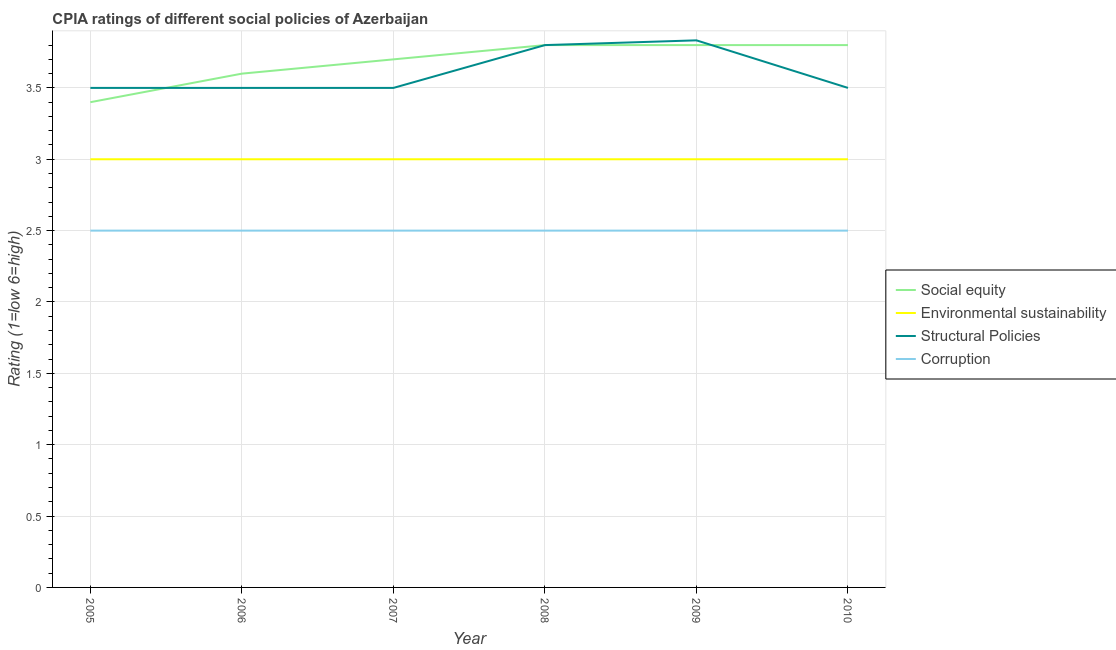Does the line corresponding to cpia rating of corruption intersect with the line corresponding to cpia rating of environmental sustainability?
Your answer should be compact. No. Across all years, what is the maximum cpia rating of environmental sustainability?
Offer a terse response. 3. Across all years, what is the minimum cpia rating of structural policies?
Your answer should be compact. 3.5. In which year was the cpia rating of social equity minimum?
Provide a short and direct response. 2005. What is the total cpia rating of social equity in the graph?
Ensure brevity in your answer.  22.1. What is the difference between the cpia rating of social equity in 2005 and that in 2009?
Ensure brevity in your answer.  -0.4. What is the average cpia rating of environmental sustainability per year?
Offer a very short reply. 3. In the year 2010, what is the difference between the cpia rating of corruption and cpia rating of environmental sustainability?
Offer a very short reply. -0.5. What is the ratio of the cpia rating of structural policies in 2007 to that in 2009?
Keep it short and to the point. 0.91. What is the difference between the highest and the second highest cpia rating of environmental sustainability?
Keep it short and to the point. 0. What is the difference between the highest and the lowest cpia rating of structural policies?
Provide a succinct answer. 0.33. In how many years, is the cpia rating of social equity greater than the average cpia rating of social equity taken over all years?
Your response must be concise. 4. Is the sum of the cpia rating of corruption in 2005 and 2010 greater than the maximum cpia rating of environmental sustainability across all years?
Give a very brief answer. Yes. Is it the case that in every year, the sum of the cpia rating of structural policies and cpia rating of corruption is greater than the sum of cpia rating of environmental sustainability and cpia rating of social equity?
Offer a terse response. No. Is the cpia rating of environmental sustainability strictly less than the cpia rating of structural policies over the years?
Your answer should be very brief. Yes. What is the difference between two consecutive major ticks on the Y-axis?
Give a very brief answer. 0.5. Are the values on the major ticks of Y-axis written in scientific E-notation?
Your answer should be compact. No. Does the graph contain grids?
Offer a terse response. Yes. What is the title of the graph?
Give a very brief answer. CPIA ratings of different social policies of Azerbaijan. Does "Mammal species" appear as one of the legend labels in the graph?
Provide a short and direct response. No. What is the label or title of the Y-axis?
Your answer should be compact. Rating (1=low 6=high). What is the Rating (1=low 6=high) in Social equity in 2005?
Your answer should be very brief. 3.4. What is the Rating (1=low 6=high) of Environmental sustainability in 2005?
Your answer should be very brief. 3. What is the Rating (1=low 6=high) in Corruption in 2005?
Your response must be concise. 2.5. What is the Rating (1=low 6=high) of Social equity in 2007?
Make the answer very short. 3.7. What is the Rating (1=low 6=high) in Environmental sustainability in 2007?
Offer a very short reply. 3. What is the Rating (1=low 6=high) in Structural Policies in 2007?
Your response must be concise. 3.5. What is the Rating (1=low 6=high) of Corruption in 2007?
Make the answer very short. 2.5. What is the Rating (1=low 6=high) of Environmental sustainability in 2008?
Ensure brevity in your answer.  3. What is the Rating (1=low 6=high) in Social equity in 2009?
Your answer should be very brief. 3.8. What is the Rating (1=low 6=high) of Structural Policies in 2009?
Your answer should be compact. 3.83. What is the Rating (1=low 6=high) in Social equity in 2010?
Your answer should be very brief. 3.8. What is the Rating (1=low 6=high) of Environmental sustainability in 2010?
Offer a very short reply. 3. What is the Rating (1=low 6=high) of Structural Policies in 2010?
Ensure brevity in your answer.  3.5. What is the Rating (1=low 6=high) in Corruption in 2010?
Keep it short and to the point. 2.5. Across all years, what is the maximum Rating (1=low 6=high) of Social equity?
Your answer should be very brief. 3.8. Across all years, what is the maximum Rating (1=low 6=high) in Structural Policies?
Ensure brevity in your answer.  3.83. Across all years, what is the minimum Rating (1=low 6=high) in Social equity?
Make the answer very short. 3.4. Across all years, what is the minimum Rating (1=low 6=high) in Environmental sustainability?
Offer a terse response. 3. What is the total Rating (1=low 6=high) of Social equity in the graph?
Give a very brief answer. 22.1. What is the total Rating (1=low 6=high) in Structural Policies in the graph?
Give a very brief answer. 21.63. What is the difference between the Rating (1=low 6=high) of Environmental sustainability in 2005 and that in 2006?
Keep it short and to the point. 0. What is the difference between the Rating (1=low 6=high) of Corruption in 2005 and that in 2006?
Ensure brevity in your answer.  0. What is the difference between the Rating (1=low 6=high) in Corruption in 2005 and that in 2007?
Provide a succinct answer. 0. What is the difference between the Rating (1=low 6=high) in Environmental sustainability in 2005 and that in 2008?
Provide a short and direct response. 0. What is the difference between the Rating (1=low 6=high) in Structural Policies in 2005 and that in 2008?
Give a very brief answer. -0.3. What is the difference between the Rating (1=low 6=high) of Corruption in 2005 and that in 2008?
Ensure brevity in your answer.  0. What is the difference between the Rating (1=low 6=high) in Social equity in 2005 and that in 2009?
Make the answer very short. -0.4. What is the difference between the Rating (1=low 6=high) of Environmental sustainability in 2005 and that in 2009?
Your answer should be very brief. 0. What is the difference between the Rating (1=low 6=high) in Structural Policies in 2005 and that in 2009?
Give a very brief answer. -0.33. What is the difference between the Rating (1=low 6=high) in Corruption in 2005 and that in 2009?
Ensure brevity in your answer.  0. What is the difference between the Rating (1=low 6=high) of Social equity in 2005 and that in 2010?
Provide a succinct answer. -0.4. What is the difference between the Rating (1=low 6=high) in Structural Policies in 2006 and that in 2007?
Provide a succinct answer. 0. What is the difference between the Rating (1=low 6=high) of Social equity in 2006 and that in 2008?
Your response must be concise. -0.2. What is the difference between the Rating (1=low 6=high) of Structural Policies in 2006 and that in 2008?
Ensure brevity in your answer.  -0.3. What is the difference between the Rating (1=low 6=high) in Corruption in 2006 and that in 2008?
Keep it short and to the point. 0. What is the difference between the Rating (1=low 6=high) in Environmental sustainability in 2006 and that in 2010?
Your response must be concise. 0. What is the difference between the Rating (1=low 6=high) of Structural Policies in 2006 and that in 2010?
Offer a very short reply. 0. What is the difference between the Rating (1=low 6=high) in Social equity in 2007 and that in 2008?
Offer a terse response. -0.1. What is the difference between the Rating (1=low 6=high) in Environmental sustainability in 2007 and that in 2008?
Keep it short and to the point. 0. What is the difference between the Rating (1=low 6=high) in Structural Policies in 2007 and that in 2008?
Your answer should be compact. -0.3. What is the difference between the Rating (1=low 6=high) in Corruption in 2007 and that in 2008?
Provide a short and direct response. 0. What is the difference between the Rating (1=low 6=high) in Environmental sustainability in 2007 and that in 2009?
Offer a very short reply. 0. What is the difference between the Rating (1=low 6=high) in Environmental sustainability in 2007 and that in 2010?
Provide a succinct answer. 0. What is the difference between the Rating (1=low 6=high) of Structural Policies in 2007 and that in 2010?
Make the answer very short. 0. What is the difference between the Rating (1=low 6=high) in Corruption in 2007 and that in 2010?
Your answer should be very brief. 0. What is the difference between the Rating (1=low 6=high) of Environmental sustainability in 2008 and that in 2009?
Offer a terse response. 0. What is the difference between the Rating (1=low 6=high) of Structural Policies in 2008 and that in 2009?
Make the answer very short. -0.03. What is the difference between the Rating (1=low 6=high) in Corruption in 2008 and that in 2009?
Keep it short and to the point. 0. What is the difference between the Rating (1=low 6=high) of Structural Policies in 2008 and that in 2010?
Your response must be concise. 0.3. What is the difference between the Rating (1=low 6=high) of Corruption in 2008 and that in 2010?
Ensure brevity in your answer.  0. What is the difference between the Rating (1=low 6=high) in Structural Policies in 2009 and that in 2010?
Your answer should be compact. 0.33. What is the difference between the Rating (1=low 6=high) of Corruption in 2009 and that in 2010?
Offer a very short reply. 0. What is the difference between the Rating (1=low 6=high) of Environmental sustainability in 2005 and the Rating (1=low 6=high) of Structural Policies in 2006?
Ensure brevity in your answer.  -0.5. What is the difference between the Rating (1=low 6=high) of Structural Policies in 2005 and the Rating (1=low 6=high) of Corruption in 2006?
Provide a succinct answer. 1. What is the difference between the Rating (1=low 6=high) of Social equity in 2005 and the Rating (1=low 6=high) of Structural Policies in 2007?
Provide a succinct answer. -0.1. What is the difference between the Rating (1=low 6=high) of Environmental sustainability in 2005 and the Rating (1=low 6=high) of Structural Policies in 2007?
Provide a succinct answer. -0.5. What is the difference between the Rating (1=low 6=high) of Social equity in 2005 and the Rating (1=low 6=high) of Structural Policies in 2008?
Ensure brevity in your answer.  -0.4. What is the difference between the Rating (1=low 6=high) of Social equity in 2005 and the Rating (1=low 6=high) of Corruption in 2008?
Provide a succinct answer. 0.9. What is the difference between the Rating (1=low 6=high) in Environmental sustainability in 2005 and the Rating (1=low 6=high) in Corruption in 2008?
Give a very brief answer. 0.5. What is the difference between the Rating (1=low 6=high) in Social equity in 2005 and the Rating (1=low 6=high) in Environmental sustainability in 2009?
Your response must be concise. 0.4. What is the difference between the Rating (1=low 6=high) of Social equity in 2005 and the Rating (1=low 6=high) of Structural Policies in 2009?
Keep it short and to the point. -0.43. What is the difference between the Rating (1=low 6=high) in Environmental sustainability in 2005 and the Rating (1=low 6=high) in Structural Policies in 2009?
Ensure brevity in your answer.  -0.83. What is the difference between the Rating (1=low 6=high) of Social equity in 2005 and the Rating (1=low 6=high) of Corruption in 2010?
Keep it short and to the point. 0.9. What is the difference between the Rating (1=low 6=high) of Social equity in 2006 and the Rating (1=low 6=high) of Environmental sustainability in 2007?
Provide a short and direct response. 0.6. What is the difference between the Rating (1=low 6=high) of Social equity in 2006 and the Rating (1=low 6=high) of Corruption in 2007?
Give a very brief answer. 1.1. What is the difference between the Rating (1=low 6=high) in Environmental sustainability in 2006 and the Rating (1=low 6=high) in Structural Policies in 2007?
Give a very brief answer. -0.5. What is the difference between the Rating (1=low 6=high) of Social equity in 2006 and the Rating (1=low 6=high) of Environmental sustainability in 2008?
Offer a terse response. 0.6. What is the difference between the Rating (1=low 6=high) in Social equity in 2006 and the Rating (1=low 6=high) in Structural Policies in 2008?
Offer a very short reply. -0.2. What is the difference between the Rating (1=low 6=high) of Environmental sustainability in 2006 and the Rating (1=low 6=high) of Structural Policies in 2008?
Provide a succinct answer. -0.8. What is the difference between the Rating (1=low 6=high) of Environmental sustainability in 2006 and the Rating (1=low 6=high) of Corruption in 2008?
Provide a succinct answer. 0.5. What is the difference between the Rating (1=low 6=high) in Structural Policies in 2006 and the Rating (1=low 6=high) in Corruption in 2008?
Give a very brief answer. 1. What is the difference between the Rating (1=low 6=high) in Social equity in 2006 and the Rating (1=low 6=high) in Structural Policies in 2009?
Offer a very short reply. -0.23. What is the difference between the Rating (1=low 6=high) of Social equity in 2006 and the Rating (1=low 6=high) of Corruption in 2009?
Provide a succinct answer. 1.1. What is the difference between the Rating (1=low 6=high) in Environmental sustainability in 2006 and the Rating (1=low 6=high) in Structural Policies in 2009?
Ensure brevity in your answer.  -0.83. What is the difference between the Rating (1=low 6=high) of Structural Policies in 2006 and the Rating (1=low 6=high) of Corruption in 2009?
Offer a terse response. 1. What is the difference between the Rating (1=low 6=high) of Social equity in 2006 and the Rating (1=low 6=high) of Structural Policies in 2010?
Offer a terse response. 0.1. What is the difference between the Rating (1=low 6=high) of Environmental sustainability in 2006 and the Rating (1=low 6=high) of Structural Policies in 2010?
Keep it short and to the point. -0.5. What is the difference between the Rating (1=low 6=high) of Social equity in 2007 and the Rating (1=low 6=high) of Environmental sustainability in 2008?
Make the answer very short. 0.7. What is the difference between the Rating (1=low 6=high) of Social equity in 2007 and the Rating (1=low 6=high) of Structural Policies in 2008?
Provide a short and direct response. -0.1. What is the difference between the Rating (1=low 6=high) in Structural Policies in 2007 and the Rating (1=low 6=high) in Corruption in 2008?
Offer a very short reply. 1. What is the difference between the Rating (1=low 6=high) in Social equity in 2007 and the Rating (1=low 6=high) in Environmental sustainability in 2009?
Offer a very short reply. 0.7. What is the difference between the Rating (1=low 6=high) of Social equity in 2007 and the Rating (1=low 6=high) of Structural Policies in 2009?
Your answer should be compact. -0.13. What is the difference between the Rating (1=low 6=high) in Social equity in 2007 and the Rating (1=low 6=high) in Corruption in 2009?
Your response must be concise. 1.2. What is the difference between the Rating (1=low 6=high) of Structural Policies in 2007 and the Rating (1=low 6=high) of Corruption in 2009?
Your answer should be compact. 1. What is the difference between the Rating (1=low 6=high) of Social equity in 2007 and the Rating (1=low 6=high) of Structural Policies in 2010?
Your response must be concise. 0.2. What is the difference between the Rating (1=low 6=high) in Environmental sustainability in 2007 and the Rating (1=low 6=high) in Structural Policies in 2010?
Ensure brevity in your answer.  -0.5. What is the difference between the Rating (1=low 6=high) in Social equity in 2008 and the Rating (1=low 6=high) in Environmental sustainability in 2009?
Offer a very short reply. 0.8. What is the difference between the Rating (1=low 6=high) in Social equity in 2008 and the Rating (1=low 6=high) in Structural Policies in 2009?
Your answer should be very brief. -0.03. What is the difference between the Rating (1=low 6=high) of Environmental sustainability in 2008 and the Rating (1=low 6=high) of Structural Policies in 2009?
Provide a succinct answer. -0.83. What is the difference between the Rating (1=low 6=high) of Social equity in 2008 and the Rating (1=low 6=high) of Corruption in 2010?
Ensure brevity in your answer.  1.3. What is the difference between the Rating (1=low 6=high) of Environmental sustainability in 2008 and the Rating (1=low 6=high) of Structural Policies in 2010?
Your answer should be compact. -0.5. What is the difference between the Rating (1=low 6=high) of Environmental sustainability in 2008 and the Rating (1=low 6=high) of Corruption in 2010?
Offer a terse response. 0.5. What is the difference between the Rating (1=low 6=high) in Structural Policies in 2008 and the Rating (1=low 6=high) in Corruption in 2010?
Give a very brief answer. 1.3. What is the difference between the Rating (1=low 6=high) of Social equity in 2009 and the Rating (1=low 6=high) of Environmental sustainability in 2010?
Offer a terse response. 0.8. What is the difference between the Rating (1=low 6=high) of Social equity in 2009 and the Rating (1=low 6=high) of Structural Policies in 2010?
Make the answer very short. 0.3. What is the difference between the Rating (1=low 6=high) of Environmental sustainability in 2009 and the Rating (1=low 6=high) of Corruption in 2010?
Your answer should be very brief. 0.5. What is the difference between the Rating (1=low 6=high) in Structural Policies in 2009 and the Rating (1=low 6=high) in Corruption in 2010?
Your answer should be compact. 1.33. What is the average Rating (1=low 6=high) of Social equity per year?
Provide a short and direct response. 3.68. What is the average Rating (1=low 6=high) in Environmental sustainability per year?
Ensure brevity in your answer.  3. What is the average Rating (1=low 6=high) in Structural Policies per year?
Provide a succinct answer. 3.61. In the year 2005, what is the difference between the Rating (1=low 6=high) in Social equity and Rating (1=low 6=high) in Structural Policies?
Provide a succinct answer. -0.1. In the year 2005, what is the difference between the Rating (1=low 6=high) in Environmental sustainability and Rating (1=low 6=high) in Structural Policies?
Provide a short and direct response. -0.5. In the year 2005, what is the difference between the Rating (1=low 6=high) of Structural Policies and Rating (1=low 6=high) of Corruption?
Offer a very short reply. 1. In the year 2006, what is the difference between the Rating (1=low 6=high) in Social equity and Rating (1=low 6=high) in Environmental sustainability?
Provide a short and direct response. 0.6. In the year 2006, what is the difference between the Rating (1=low 6=high) in Social equity and Rating (1=low 6=high) in Structural Policies?
Keep it short and to the point. 0.1. In the year 2006, what is the difference between the Rating (1=low 6=high) of Social equity and Rating (1=low 6=high) of Corruption?
Offer a very short reply. 1.1. In the year 2006, what is the difference between the Rating (1=low 6=high) in Environmental sustainability and Rating (1=low 6=high) in Structural Policies?
Offer a terse response. -0.5. In the year 2006, what is the difference between the Rating (1=low 6=high) of Structural Policies and Rating (1=low 6=high) of Corruption?
Give a very brief answer. 1. In the year 2007, what is the difference between the Rating (1=low 6=high) in Environmental sustainability and Rating (1=low 6=high) in Structural Policies?
Keep it short and to the point. -0.5. In the year 2007, what is the difference between the Rating (1=low 6=high) of Environmental sustainability and Rating (1=low 6=high) of Corruption?
Ensure brevity in your answer.  0.5. In the year 2008, what is the difference between the Rating (1=low 6=high) in Social equity and Rating (1=low 6=high) in Environmental sustainability?
Your answer should be very brief. 0.8. In the year 2008, what is the difference between the Rating (1=low 6=high) of Social equity and Rating (1=low 6=high) of Corruption?
Your answer should be very brief. 1.3. In the year 2008, what is the difference between the Rating (1=low 6=high) in Environmental sustainability and Rating (1=low 6=high) in Corruption?
Your response must be concise. 0.5. In the year 2009, what is the difference between the Rating (1=low 6=high) of Social equity and Rating (1=low 6=high) of Structural Policies?
Give a very brief answer. -0.03. In the year 2009, what is the difference between the Rating (1=low 6=high) of Environmental sustainability and Rating (1=low 6=high) of Structural Policies?
Your answer should be compact. -0.83. In the year 2009, what is the difference between the Rating (1=low 6=high) in Environmental sustainability and Rating (1=low 6=high) in Corruption?
Ensure brevity in your answer.  0.5. In the year 2010, what is the difference between the Rating (1=low 6=high) of Environmental sustainability and Rating (1=low 6=high) of Structural Policies?
Your response must be concise. -0.5. What is the ratio of the Rating (1=low 6=high) of Social equity in 2005 to that in 2006?
Give a very brief answer. 0.94. What is the ratio of the Rating (1=low 6=high) of Environmental sustainability in 2005 to that in 2006?
Provide a succinct answer. 1. What is the ratio of the Rating (1=low 6=high) in Social equity in 2005 to that in 2007?
Keep it short and to the point. 0.92. What is the ratio of the Rating (1=low 6=high) in Structural Policies in 2005 to that in 2007?
Give a very brief answer. 1. What is the ratio of the Rating (1=low 6=high) of Social equity in 2005 to that in 2008?
Provide a short and direct response. 0.89. What is the ratio of the Rating (1=low 6=high) in Structural Policies in 2005 to that in 2008?
Your response must be concise. 0.92. What is the ratio of the Rating (1=low 6=high) in Corruption in 2005 to that in 2008?
Your response must be concise. 1. What is the ratio of the Rating (1=low 6=high) in Social equity in 2005 to that in 2009?
Give a very brief answer. 0.89. What is the ratio of the Rating (1=low 6=high) of Corruption in 2005 to that in 2009?
Your answer should be very brief. 1. What is the ratio of the Rating (1=low 6=high) of Social equity in 2005 to that in 2010?
Give a very brief answer. 0.89. What is the ratio of the Rating (1=low 6=high) of Environmental sustainability in 2005 to that in 2010?
Provide a succinct answer. 1. What is the ratio of the Rating (1=low 6=high) in Corruption in 2006 to that in 2007?
Offer a very short reply. 1. What is the ratio of the Rating (1=low 6=high) of Structural Policies in 2006 to that in 2008?
Provide a succinct answer. 0.92. What is the ratio of the Rating (1=low 6=high) of Corruption in 2006 to that in 2008?
Give a very brief answer. 1. What is the ratio of the Rating (1=low 6=high) in Environmental sustainability in 2006 to that in 2009?
Offer a terse response. 1. What is the ratio of the Rating (1=low 6=high) in Environmental sustainability in 2006 to that in 2010?
Keep it short and to the point. 1. What is the ratio of the Rating (1=low 6=high) of Corruption in 2006 to that in 2010?
Your response must be concise. 1. What is the ratio of the Rating (1=low 6=high) in Social equity in 2007 to that in 2008?
Offer a very short reply. 0.97. What is the ratio of the Rating (1=low 6=high) in Environmental sustainability in 2007 to that in 2008?
Make the answer very short. 1. What is the ratio of the Rating (1=low 6=high) of Structural Policies in 2007 to that in 2008?
Provide a short and direct response. 0.92. What is the ratio of the Rating (1=low 6=high) in Social equity in 2007 to that in 2009?
Give a very brief answer. 0.97. What is the ratio of the Rating (1=low 6=high) in Environmental sustainability in 2007 to that in 2009?
Provide a short and direct response. 1. What is the ratio of the Rating (1=low 6=high) in Social equity in 2007 to that in 2010?
Provide a short and direct response. 0.97. What is the ratio of the Rating (1=low 6=high) in Environmental sustainability in 2007 to that in 2010?
Offer a terse response. 1. What is the ratio of the Rating (1=low 6=high) of Corruption in 2007 to that in 2010?
Keep it short and to the point. 1. What is the ratio of the Rating (1=low 6=high) of Social equity in 2008 to that in 2009?
Your response must be concise. 1. What is the ratio of the Rating (1=low 6=high) of Environmental sustainability in 2008 to that in 2009?
Offer a terse response. 1. What is the ratio of the Rating (1=low 6=high) in Structural Policies in 2008 to that in 2009?
Your response must be concise. 0.99. What is the ratio of the Rating (1=low 6=high) of Corruption in 2008 to that in 2009?
Your answer should be compact. 1. What is the ratio of the Rating (1=low 6=high) in Environmental sustainability in 2008 to that in 2010?
Ensure brevity in your answer.  1. What is the ratio of the Rating (1=low 6=high) of Structural Policies in 2008 to that in 2010?
Make the answer very short. 1.09. What is the ratio of the Rating (1=low 6=high) in Corruption in 2008 to that in 2010?
Make the answer very short. 1. What is the ratio of the Rating (1=low 6=high) of Environmental sustainability in 2009 to that in 2010?
Your answer should be very brief. 1. What is the ratio of the Rating (1=low 6=high) of Structural Policies in 2009 to that in 2010?
Your answer should be very brief. 1.1. What is the ratio of the Rating (1=low 6=high) of Corruption in 2009 to that in 2010?
Provide a succinct answer. 1. What is the difference between the highest and the second highest Rating (1=low 6=high) in Environmental sustainability?
Offer a terse response. 0. What is the difference between the highest and the second highest Rating (1=low 6=high) in Corruption?
Provide a succinct answer. 0. What is the difference between the highest and the lowest Rating (1=low 6=high) of Structural Policies?
Make the answer very short. 0.33. What is the difference between the highest and the lowest Rating (1=low 6=high) in Corruption?
Your answer should be very brief. 0. 